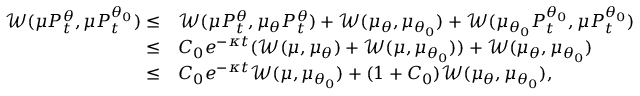Convert formula to latex. <formula><loc_0><loc_0><loc_500><loc_500>\begin{array} { r l } { \mathcal { W } ( \mu P _ { t } ^ { \theta } , \mu P _ { t } ^ { \theta _ { 0 } } ) \leq } & { \mathcal { W } ( \mu P _ { t } ^ { \theta } , \mu _ { \theta } P _ { t } ^ { \theta } ) + \mathcal { W } ( \mu _ { \theta } , \mu _ { \theta _ { 0 } } ) + \mathcal { W } ( \mu _ { \theta _ { 0 } } P _ { t } ^ { \theta _ { 0 } } , \mu P _ { t } ^ { \theta _ { 0 } } ) } \\ { \leq } & { C _ { 0 } e ^ { - \kappa t } ( \mathcal { W } ( \mu , \mu _ { \theta } ) + \mathcal { W } ( \mu , \mu _ { \theta _ { 0 } } ) ) + \mathcal { W } ( \mu _ { \theta } , \mu _ { \theta _ { 0 } } ) } \\ { \leq } & { C _ { 0 } e ^ { - \kappa t } \mathcal { W } ( \mu , \mu _ { \theta _ { 0 } } ) + ( 1 + C _ { 0 } ) \mathcal { W } ( \mu _ { \theta } , \mu _ { \theta _ { 0 } } ) , } \end{array}</formula> 